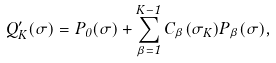<formula> <loc_0><loc_0><loc_500><loc_500>Q _ { K } ^ { \prime } ( \sigma ) = P _ { 0 } ( \sigma ) + \sum _ { \beta = 1 } ^ { K - 1 } C _ { \beta } ( \sigma _ { K } ) P _ { \beta } ( \sigma ) ,</formula> 